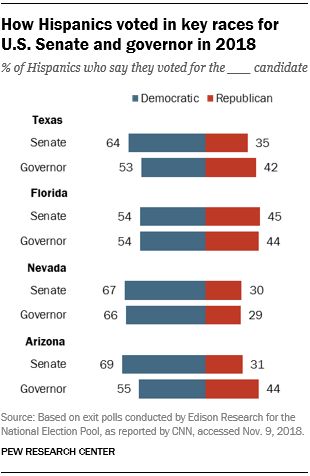Give some essential details in this illustration. The color of the Democratic bar is blue. As a result of our efforts, the total add-up value of all Democrats in Texas is 117. 